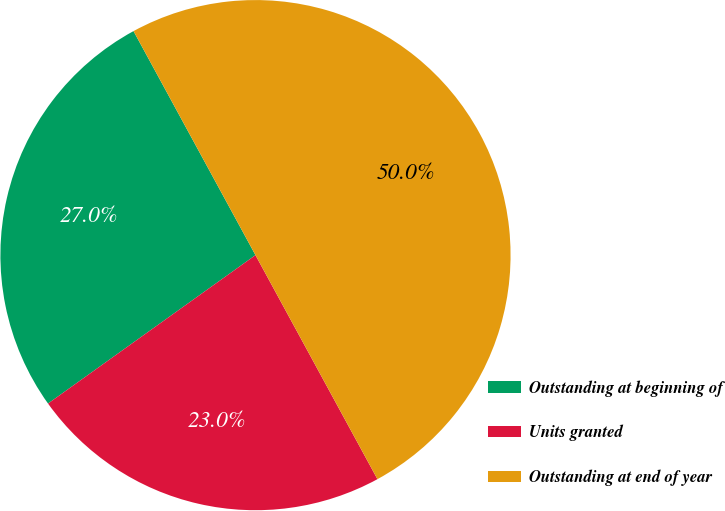Convert chart to OTSL. <chart><loc_0><loc_0><loc_500><loc_500><pie_chart><fcel>Outstanding at beginning of<fcel>Units granted<fcel>Outstanding at end of year<nl><fcel>26.95%<fcel>23.05%<fcel>50.0%<nl></chart> 